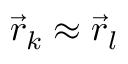<formula> <loc_0><loc_0><loc_500><loc_500>\vec { r } _ { k } \approx \vec { r } _ { l }</formula> 